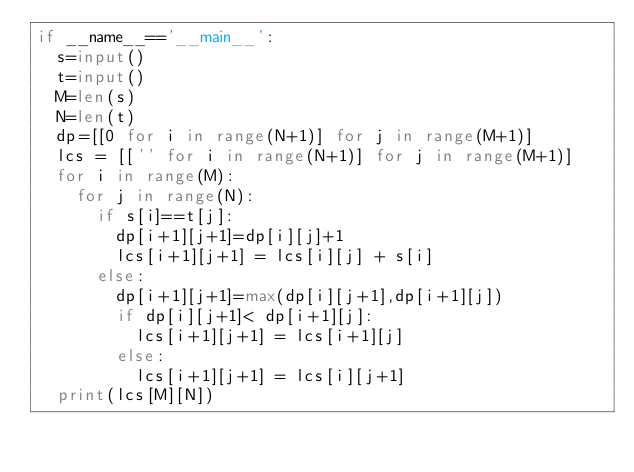<code> <loc_0><loc_0><loc_500><loc_500><_Python_>if __name__=='__main__':
	s=input()
	t=input()
	M=len(s)
	N=len(t)
	dp=[[0 for i in range(N+1)] for j in range(M+1)]
	lcs = [['' for i in range(N+1)] for j in range(M+1)]
	for i in range(M):
		for j in range(N):
			if s[i]==t[j]:
				dp[i+1][j+1]=dp[i][j]+1
				lcs[i+1][j+1] = lcs[i][j] + s[i]
			else:
				dp[i+1][j+1]=max(dp[i][j+1],dp[i+1][j])
				if dp[i][j+1]< dp[i+1][j]:
					lcs[i+1][j+1] = lcs[i+1][j]
				else:
					lcs[i+1][j+1] = lcs[i][j+1]
	print(lcs[M][N])</code> 